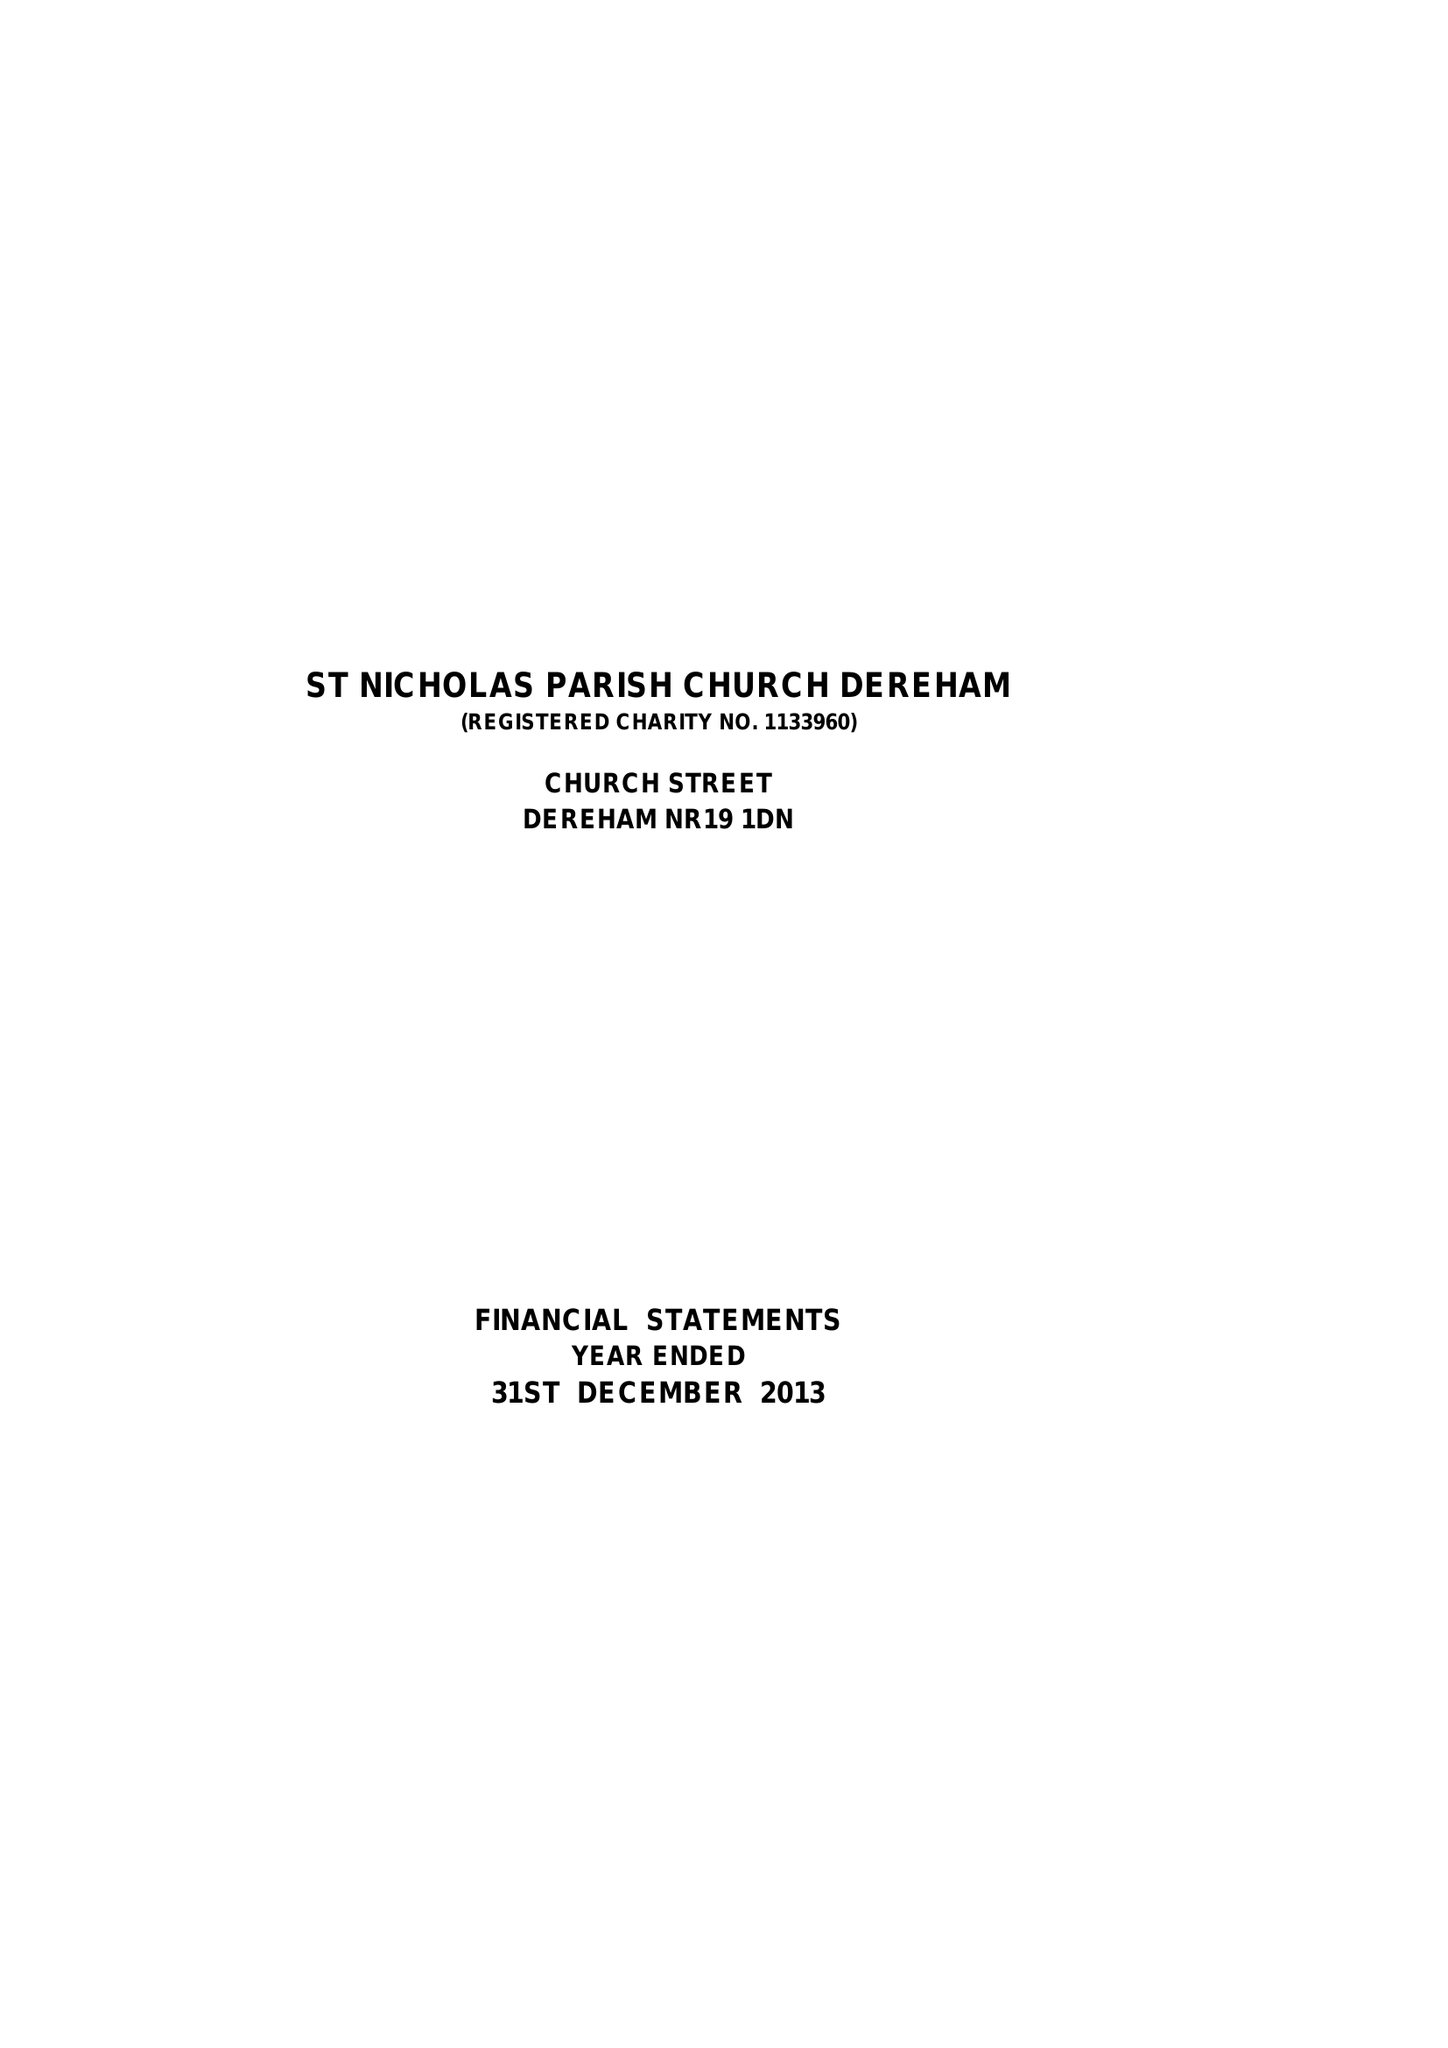What is the value for the charity_name?
Answer the question using a single word or phrase. The Parochial Church Council Of The Ecclesiastical Parish Of St Nicholas, Dereham 